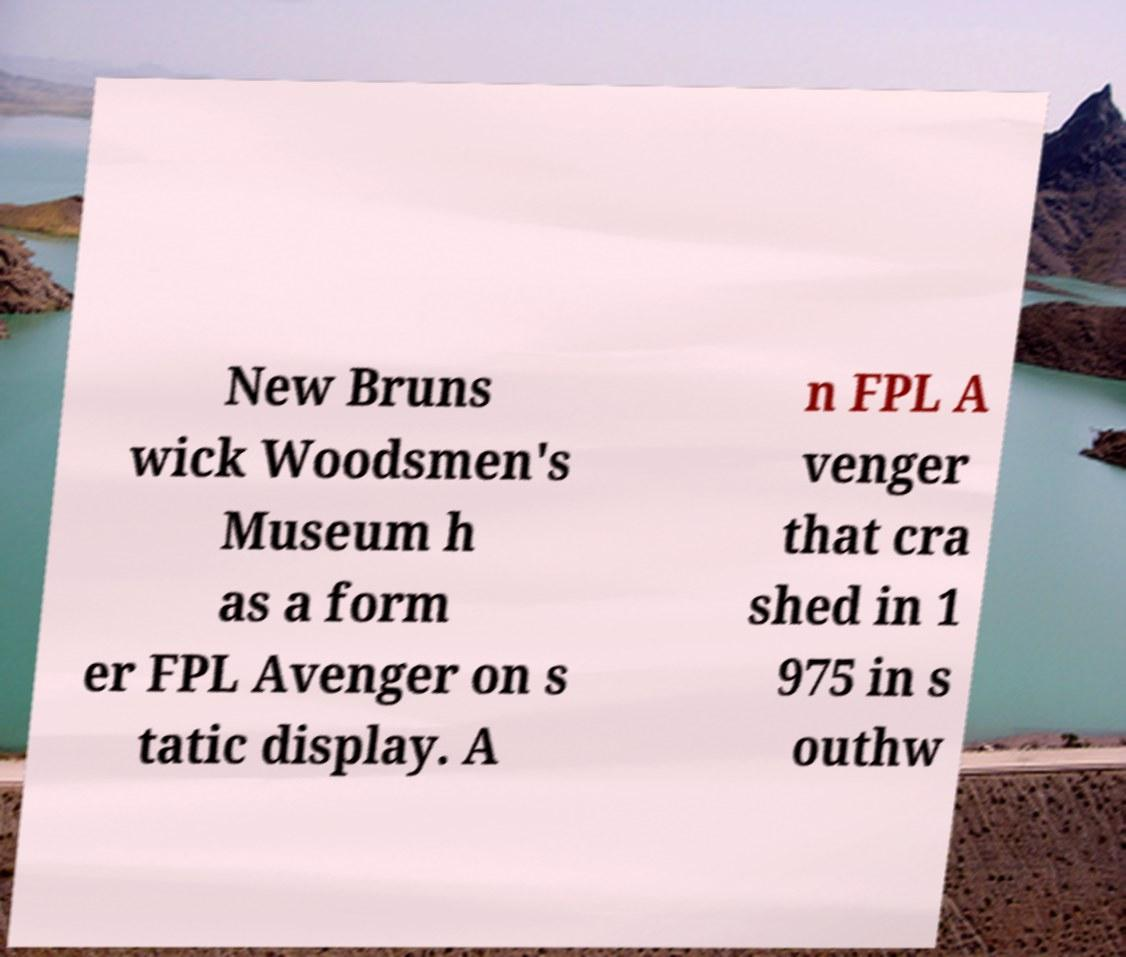What messages or text are displayed in this image? I need them in a readable, typed format. New Bruns wick Woodsmen's Museum h as a form er FPL Avenger on s tatic display. A n FPL A venger that cra shed in 1 975 in s outhw 